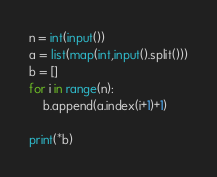Convert code to text. <code><loc_0><loc_0><loc_500><loc_500><_Python_>n = int(input())
a = list(map(int,input().split()))
b = []
for i in range(n):
    b.append(a.index(i+1)+1)

print(*b)</code> 